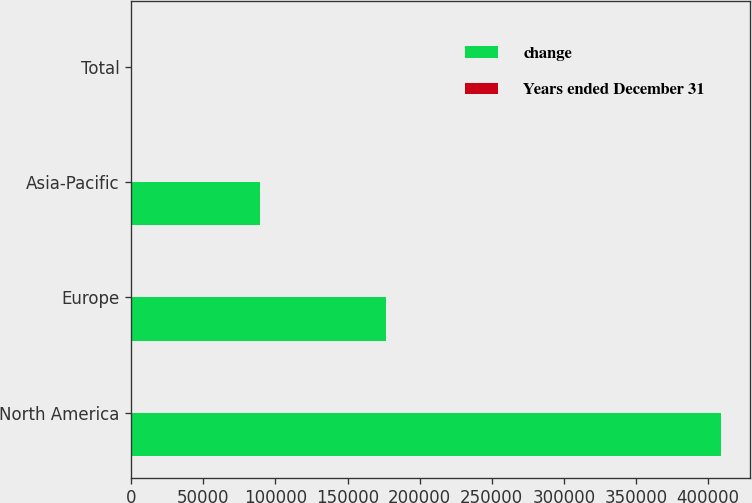Convert chart. <chart><loc_0><loc_0><loc_500><loc_500><stacked_bar_chart><ecel><fcel>North America<fcel>Europe<fcel>Asia-Pacific<fcel>Total<nl><fcel>change<fcel>408769<fcel>176937<fcel>88961<fcel>52<nl><fcel>Years ended December 31<fcel>52<fcel>22<fcel>28<fcel>40<nl></chart> 